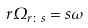<formula> <loc_0><loc_0><loc_500><loc_500>r \Omega _ { r \colon s } = s \omega</formula> 